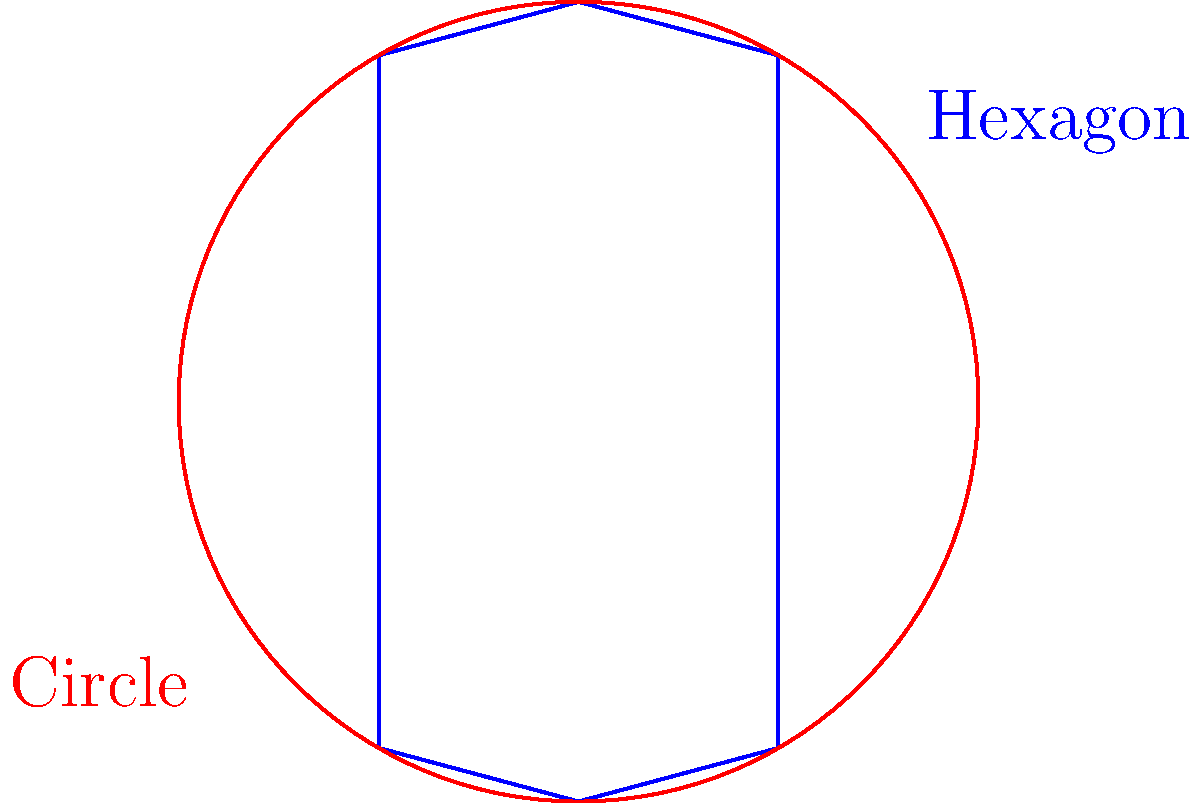In a strategic battlefield scenario, you need to optimize your troop formation for maximum defensive coverage. Given the same perimeter length, which shape provides better area coverage: a hexagonal formation or a circular formation? Justify your answer using geometric principles. To determine which shape provides better area coverage, we need to compare the areas of a hexagon and a circle with the same perimeter length. Let's approach this step-by-step:

1. Let the perimeter length be $P$.

2. For a regular hexagon:
   - Side length: $s = \frac{P}{6}$
   - Area: $A_h = \frac{3\sqrt{3}}{2}s^2 = \frac{3\sqrt{3}}{2}(\frac{P}{6})^2 = \frac{\sqrt{3}}{24}P^2$

3. For a circle:
   - Radius: $r = \frac{P}{2\pi}$
   - Area: $A_c = \pi r^2 = \pi (\frac{P}{2\pi})^2 = \frac{P^2}{4\pi}$

4. Compare the areas:
   $\frac{A_h}{A_c} = \frac{\frac{\sqrt{3}}{24}P^2}{\frac{P^2}{4\pi}} = \frac{\pi\sqrt{3}}{6} \approx 0.9069$

5. Since this ratio is less than 1, the circle has a larger area than the hexagon for the same perimeter.

6. The circle is the shape that encloses the maximum area for a given perimeter (isoperimetric inequality).

Therefore, a circular formation provides better area coverage than a hexagonal formation with the same perimeter length.
Answer: Circular formation provides better area coverage. 